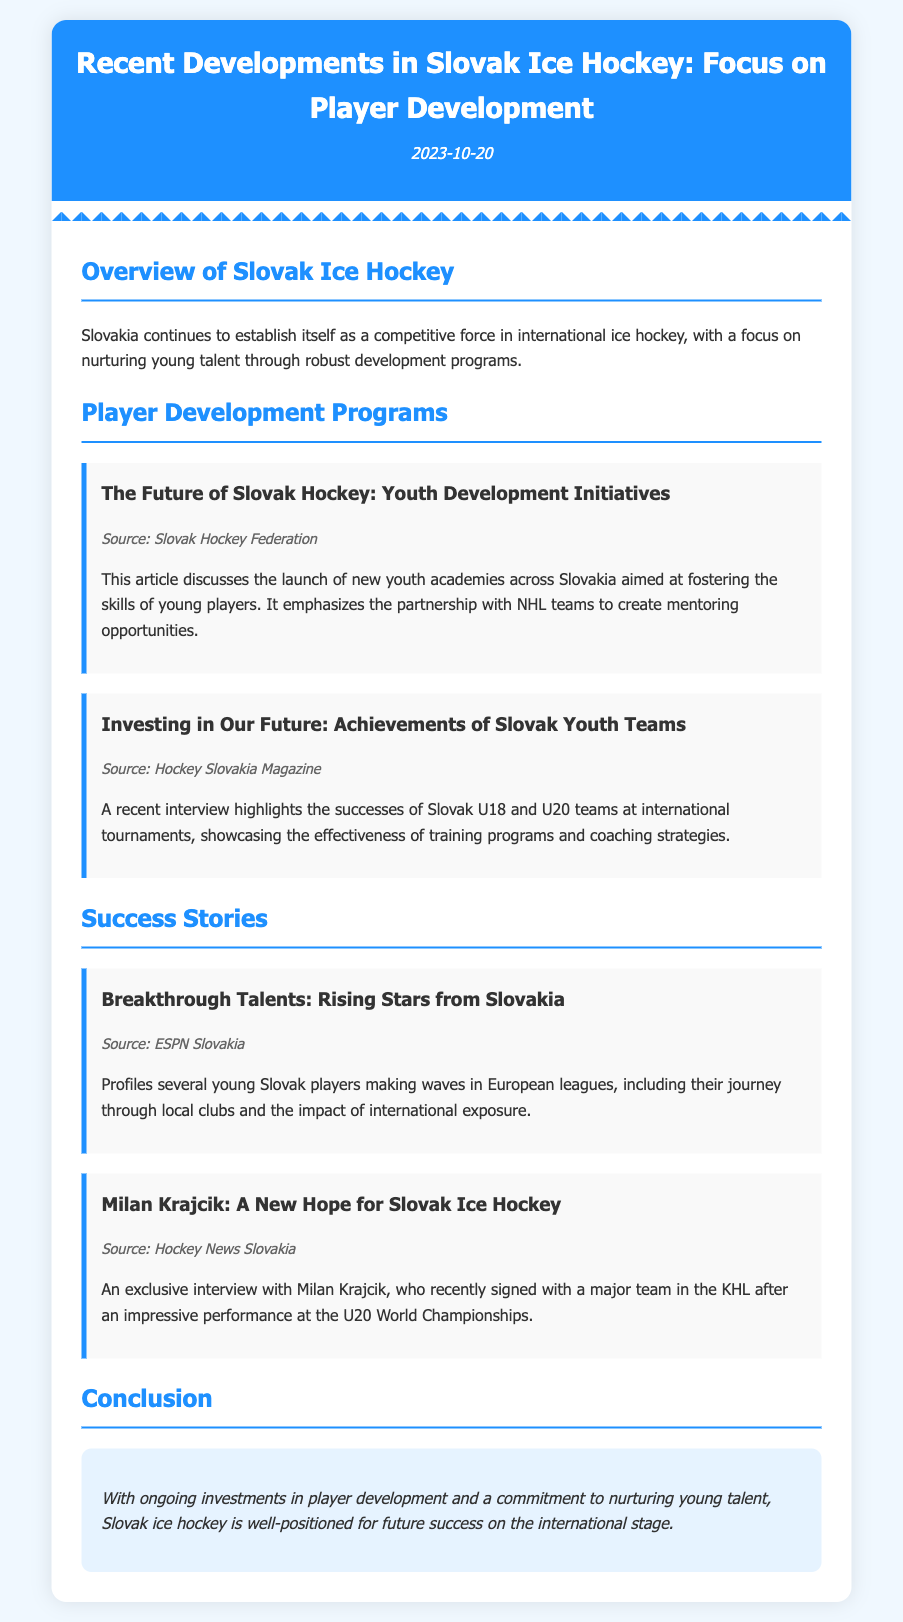What is the date of the document? The date is stated in the header of the document as "2023-10-20".
Answer: 2023-10-20 What organization launched new youth academies? The source of the article mentions the organization associated with youth development initiatives as the "Slovak Hockey Federation".
Answer: Slovak Hockey Federation Which teams highlighted their successes at international tournaments? The interview in the document discusses the achievements of Slovak U18 and U20 teams.
Answer: U18 and U20 teams Who is the young player recently signed with a major KHL team? The article mentions Milan Krajcik as the player who signed with a major KHL team.
Answer: Milan Krajcik What does the conclusion emphasize about Slovak ice hockey? The conclusion states the commitment to nurturing young talent and future success.
Answer: Future success 